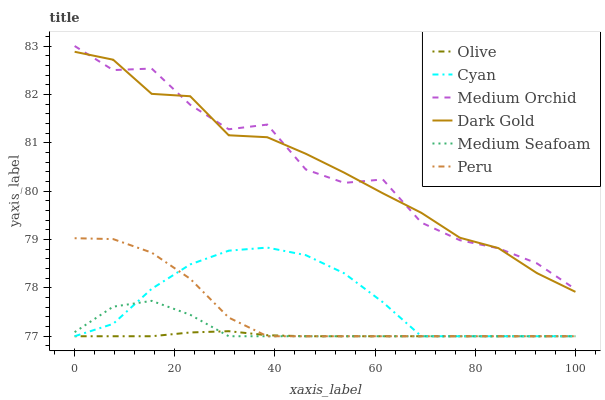Does Olive have the minimum area under the curve?
Answer yes or no. Yes. Does Medium Orchid have the maximum area under the curve?
Answer yes or no. Yes. Does Peru have the minimum area under the curve?
Answer yes or no. No. Does Peru have the maximum area under the curve?
Answer yes or no. No. Is Olive the smoothest?
Answer yes or no. Yes. Is Medium Orchid the roughest?
Answer yes or no. Yes. Is Peru the smoothest?
Answer yes or no. No. Is Peru the roughest?
Answer yes or no. No. Does Medium Orchid have the lowest value?
Answer yes or no. No. Does Medium Orchid have the highest value?
Answer yes or no. Yes. Does Peru have the highest value?
Answer yes or no. No. Is Cyan less than Medium Orchid?
Answer yes or no. Yes. Is Medium Orchid greater than Olive?
Answer yes or no. Yes. Does Medium Seafoam intersect Olive?
Answer yes or no. Yes. Is Medium Seafoam less than Olive?
Answer yes or no. No. Is Medium Seafoam greater than Olive?
Answer yes or no. No. Does Cyan intersect Medium Orchid?
Answer yes or no. No. 